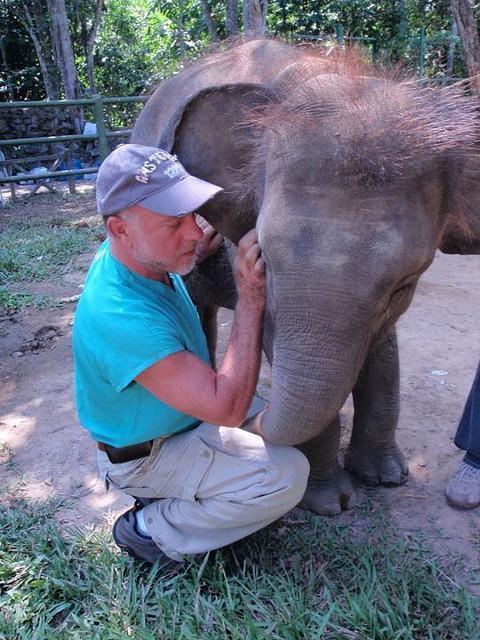How many people can be seen?
Give a very brief answer. 2. How many airplane wheels are to be seen?
Give a very brief answer. 0. 